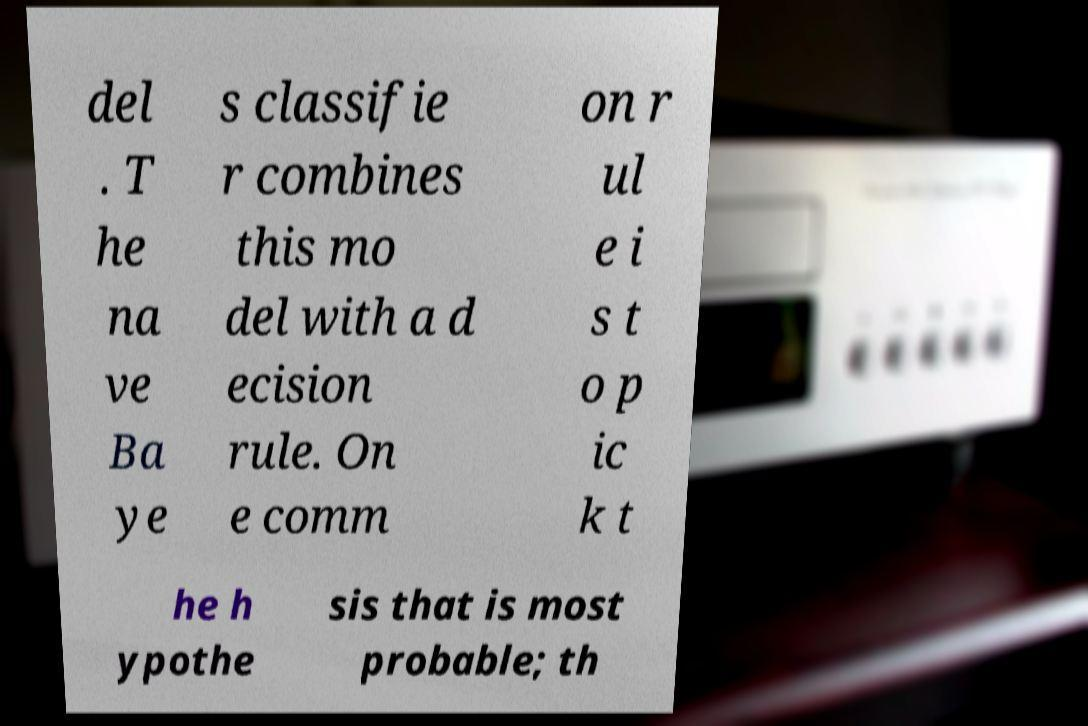Please read and relay the text visible in this image. What does it say? del . T he na ve Ba ye s classifie r combines this mo del with a d ecision rule. On e comm on r ul e i s t o p ic k t he h ypothe sis that is most probable; th 